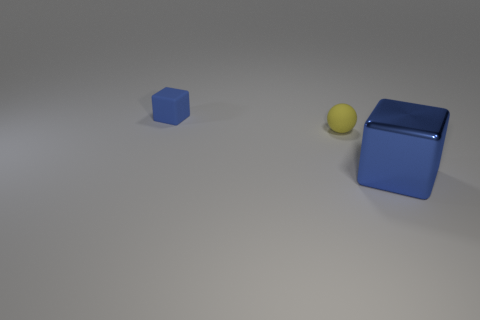The object that is in front of the small rubber cube and on the left side of the blue metallic object is what color?
Ensure brevity in your answer.  Yellow. Is there anything else that has the same color as the large block?
Offer a terse response. Yes. There is a blue object that is on the left side of the big blue cube that is in front of the blue object to the left of the big blue metal thing; what is its shape?
Give a very brief answer. Cube. The other small thing that is the same shape as the blue metallic object is what color?
Your answer should be compact. Blue. There is a small rubber thing behind the small rubber object that is on the right side of the tiny blue block; what color is it?
Your response must be concise. Blue. What size is the other blue rubber object that is the same shape as the large object?
Offer a terse response. Small. How many tiny cubes have the same material as the yellow ball?
Offer a very short reply. 1. What number of tiny things are right of the small thing to the right of the small blue matte cube?
Offer a very short reply. 0. There is a blue shiny cube; are there any big objects right of it?
Provide a short and direct response. No. Does the object that is behind the yellow object have the same shape as the yellow object?
Your answer should be compact. No. 